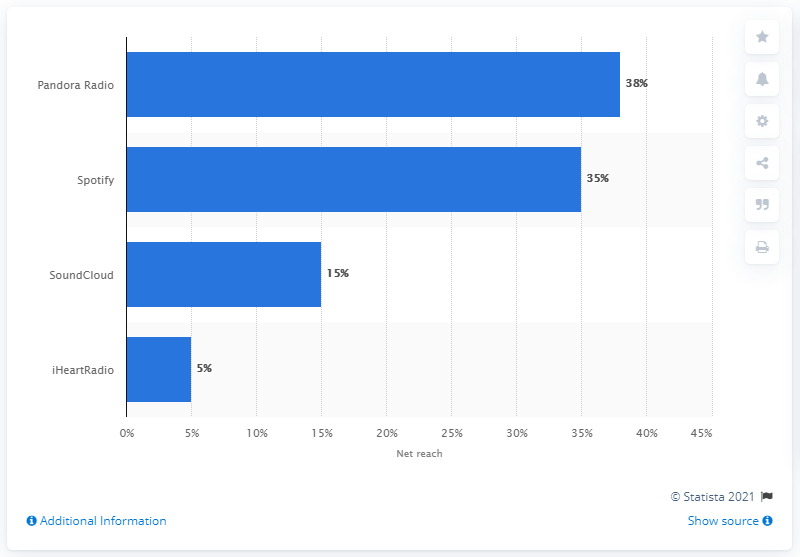Specify some key components in this picture. According to data from June 2019, the most popular streaming service in the United States was Spotify. In June 2019, 38% of people used Pandora's mobile app. 